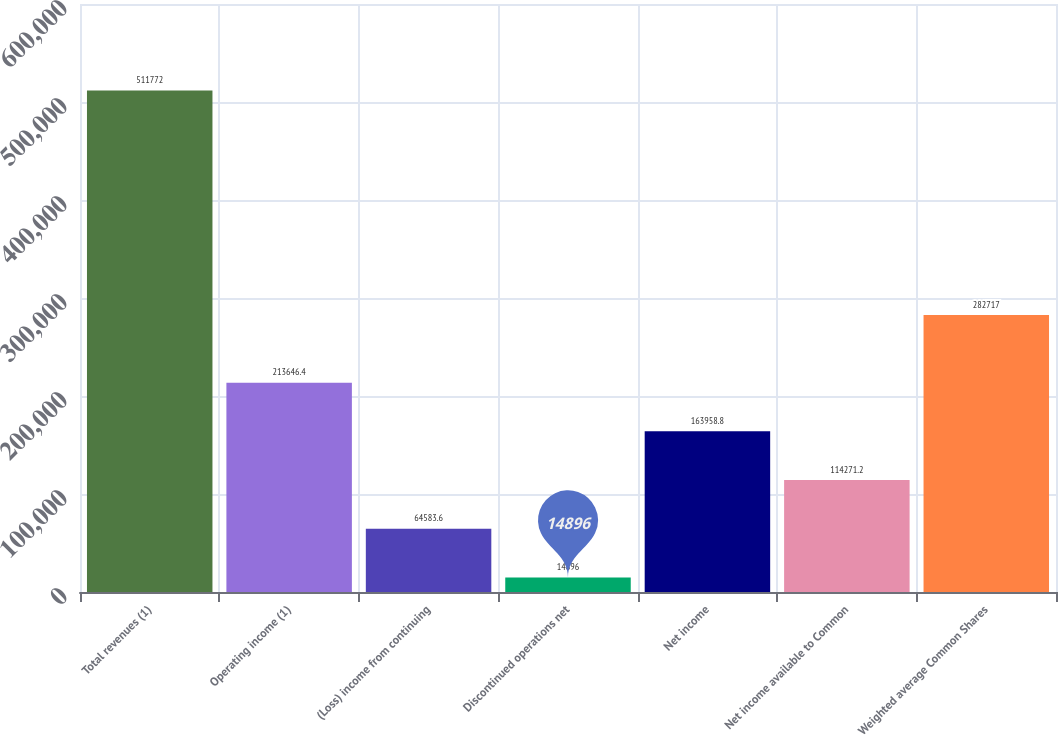Convert chart. <chart><loc_0><loc_0><loc_500><loc_500><bar_chart><fcel>Total revenues (1)<fcel>Operating income (1)<fcel>(Loss) income from continuing<fcel>Discontinued operations net<fcel>Net income<fcel>Net income available to Common<fcel>Weighted average Common Shares<nl><fcel>511772<fcel>213646<fcel>64583.6<fcel>14896<fcel>163959<fcel>114271<fcel>282717<nl></chart> 